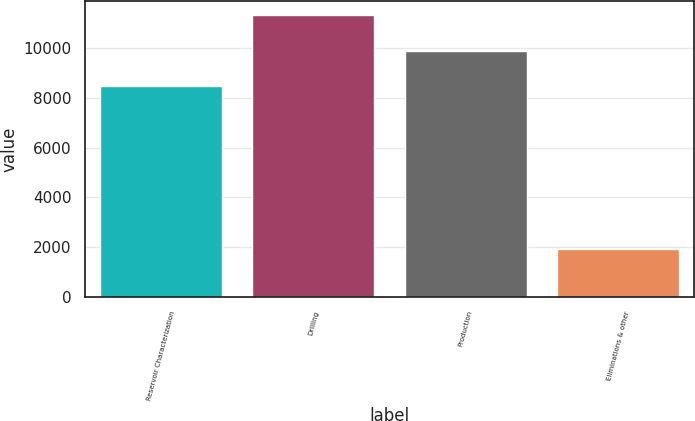Convert chart. <chart><loc_0><loc_0><loc_500><loc_500><bar_chart><fcel>Reservoir Characterization<fcel>Drilling<fcel>Production<fcel>Eliminations & other<nl><fcel>8501<fcel>11316<fcel>9889<fcel>1920<nl></chart> 